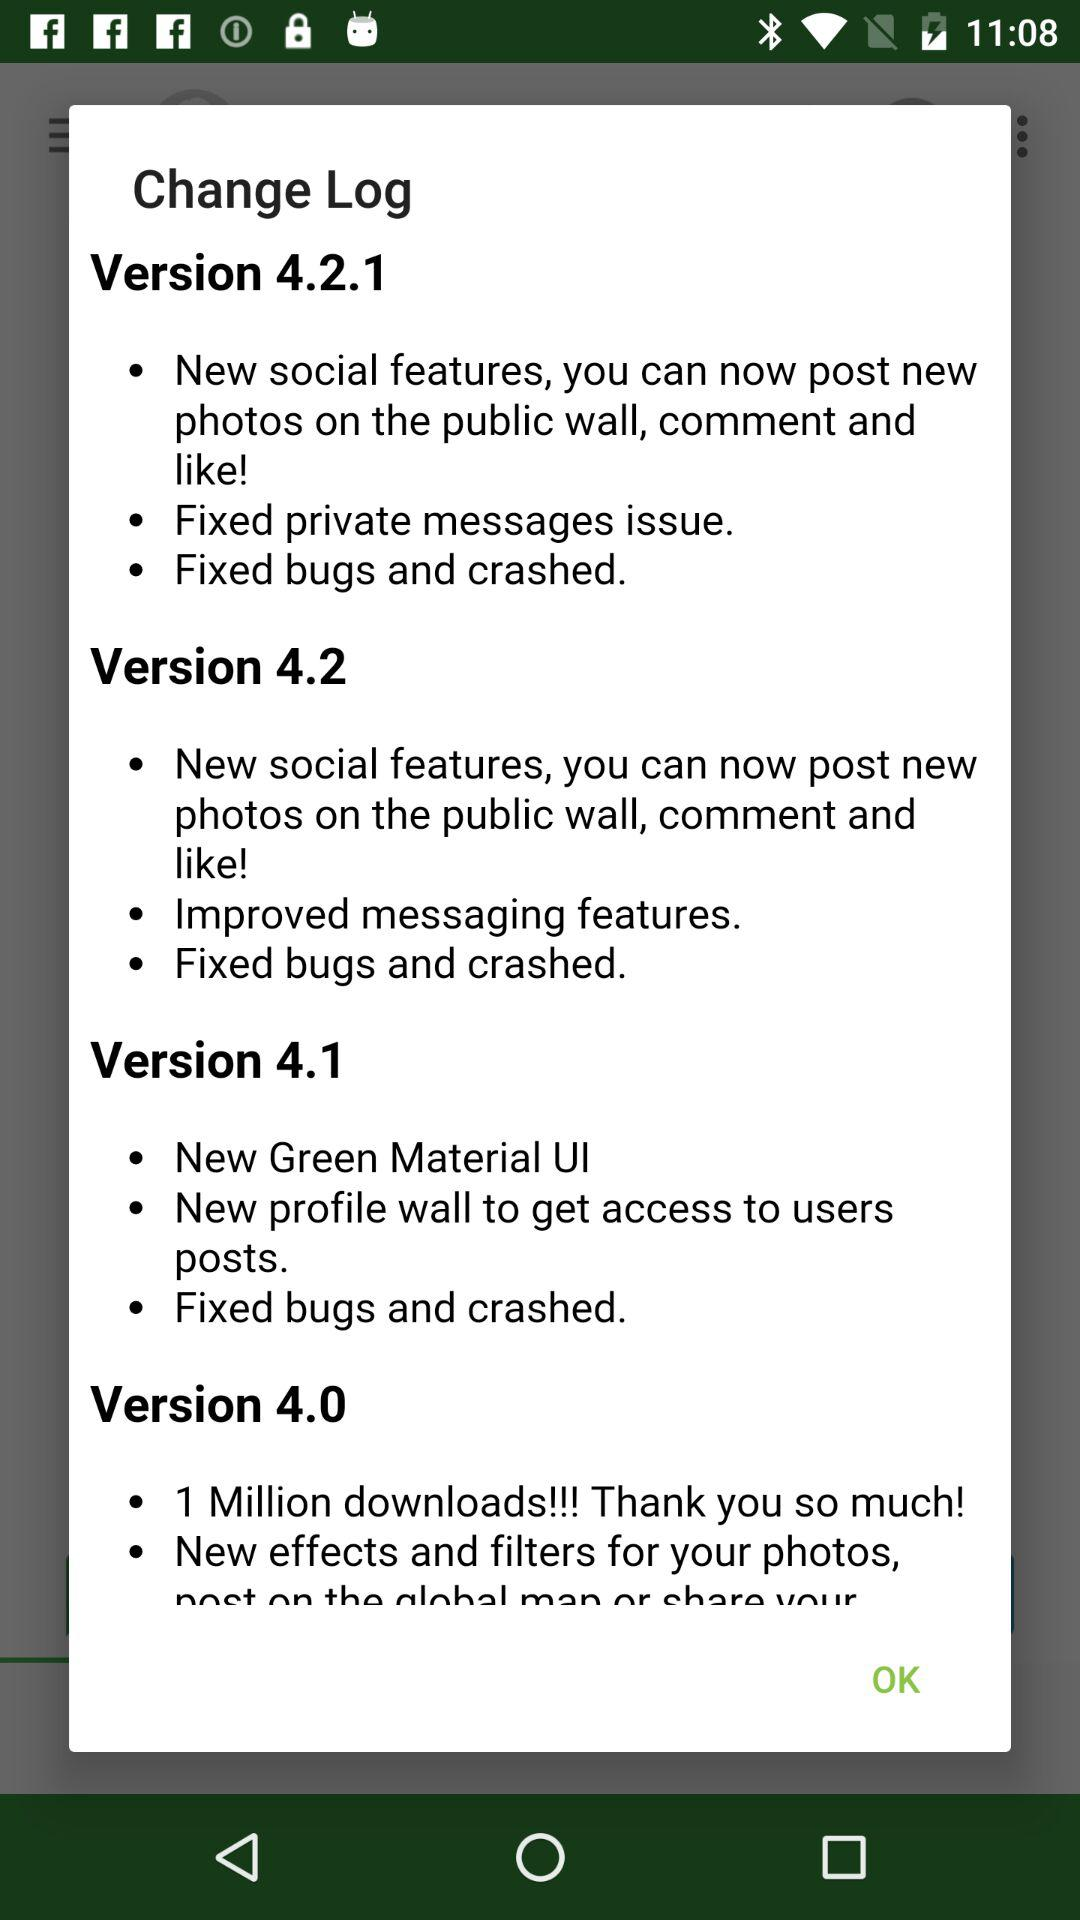What is the change log in version 4.0? Change Log in version 4.0 are 1 Million downloads!!! Thank you so much!, and New effects and filters for your photos, post on the global man or share your. 